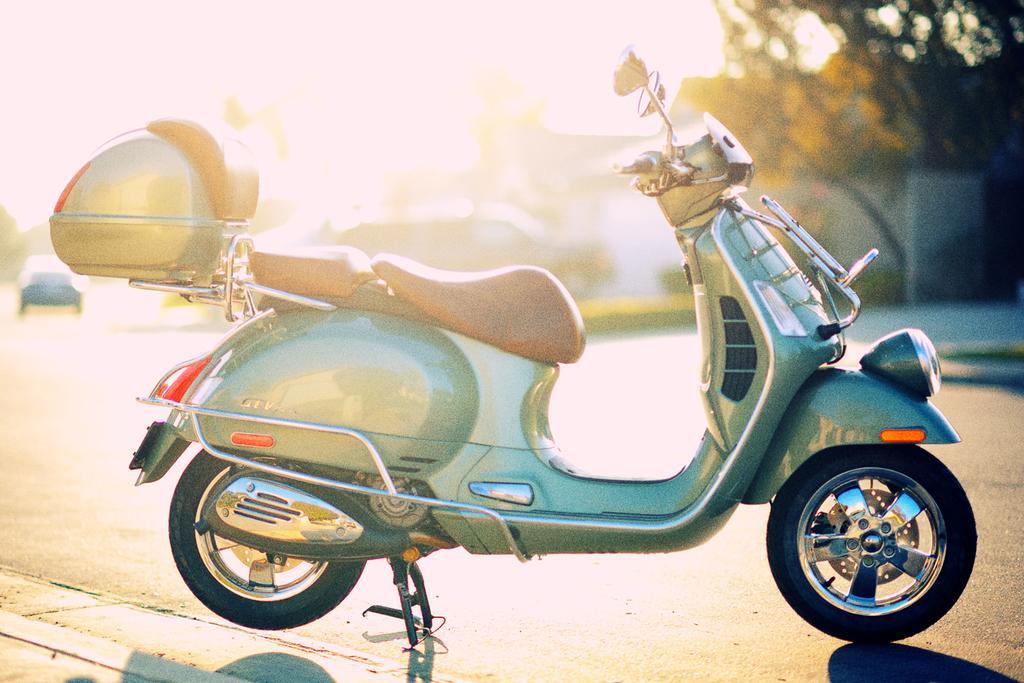Describe this image in one or two sentences. This picture shows a scooter parked on the side of the road we see trees and a car moving on the road and we see a box to the scooter on the back. 